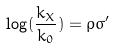<formula> <loc_0><loc_0><loc_500><loc_500>\log ( \frac { k _ { X } } { k _ { 0 } } ) = \rho \sigma ^ { \prime }</formula> 